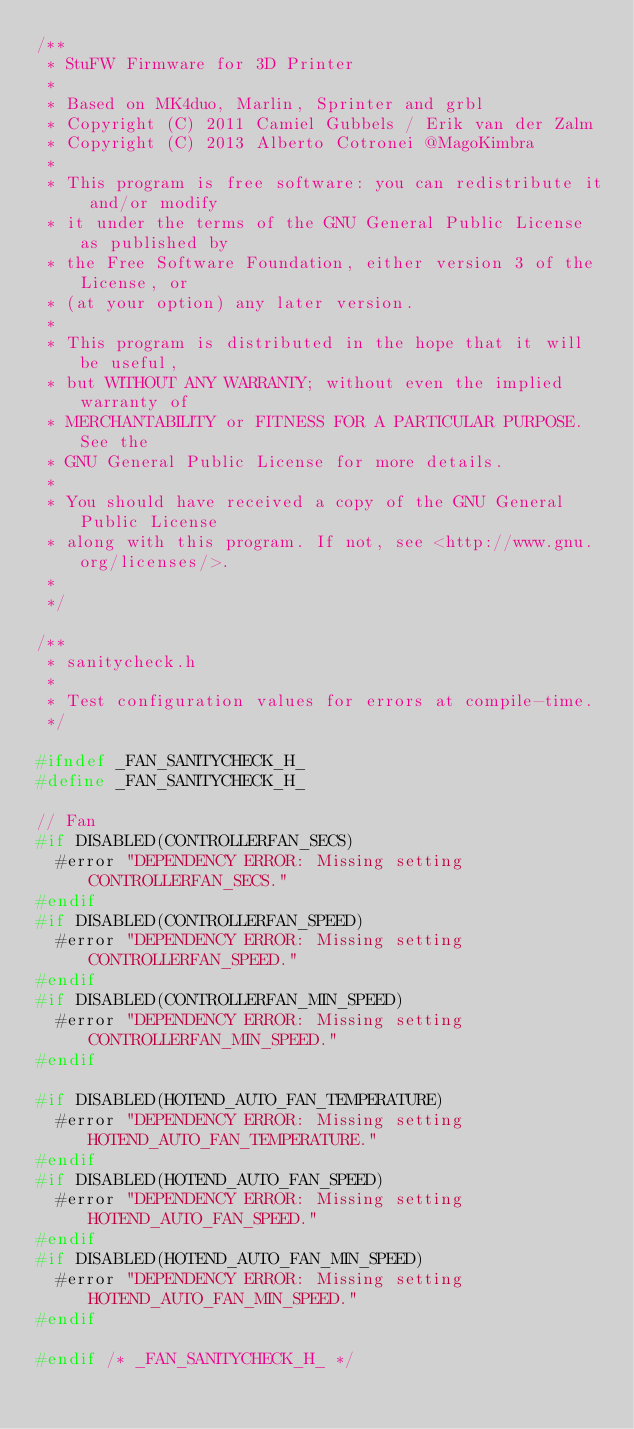Convert code to text. <code><loc_0><loc_0><loc_500><loc_500><_C_>/**
 * StuFW Firmware for 3D Printer
 *
 * Based on MK4duo, Marlin, Sprinter and grbl
 * Copyright (C) 2011 Camiel Gubbels / Erik van der Zalm
 * Copyright (C) 2013 Alberto Cotronei @MagoKimbra
 *
 * This program is free software: you can redistribute it and/or modify
 * it under the terms of the GNU General Public License as published by
 * the Free Software Foundation, either version 3 of the License, or
 * (at your option) any later version.
 *
 * This program is distributed in the hope that it will be useful,
 * but WITHOUT ANY WARRANTY; without even the implied warranty of
 * MERCHANTABILITY or FITNESS FOR A PARTICULAR PURPOSE. See the
 * GNU General Public License for more details.
 *
 * You should have received a copy of the GNU General Public License
 * along with this program. If not, see <http://www.gnu.org/licenses/>.
 *
 */

/**
 * sanitycheck.h
 *
 * Test configuration values for errors at compile-time.
 */

#ifndef _FAN_SANITYCHECK_H_
#define _FAN_SANITYCHECK_H_

// Fan
#if DISABLED(CONTROLLERFAN_SECS)
  #error "DEPENDENCY ERROR: Missing setting CONTROLLERFAN_SECS."
#endif
#if DISABLED(CONTROLLERFAN_SPEED)
  #error "DEPENDENCY ERROR: Missing setting CONTROLLERFAN_SPEED."
#endif
#if DISABLED(CONTROLLERFAN_MIN_SPEED)
  #error "DEPENDENCY ERROR: Missing setting CONTROLLERFAN_MIN_SPEED."
#endif

#if DISABLED(HOTEND_AUTO_FAN_TEMPERATURE)
  #error "DEPENDENCY ERROR: Missing setting HOTEND_AUTO_FAN_TEMPERATURE."
#endif
#if DISABLED(HOTEND_AUTO_FAN_SPEED)
  #error "DEPENDENCY ERROR: Missing setting HOTEND_AUTO_FAN_SPEED."
#endif
#if DISABLED(HOTEND_AUTO_FAN_MIN_SPEED)
  #error "DEPENDENCY ERROR: Missing setting HOTEND_AUTO_FAN_MIN_SPEED."
#endif

#endif /* _FAN_SANITYCHECK_H_ */
</code> 